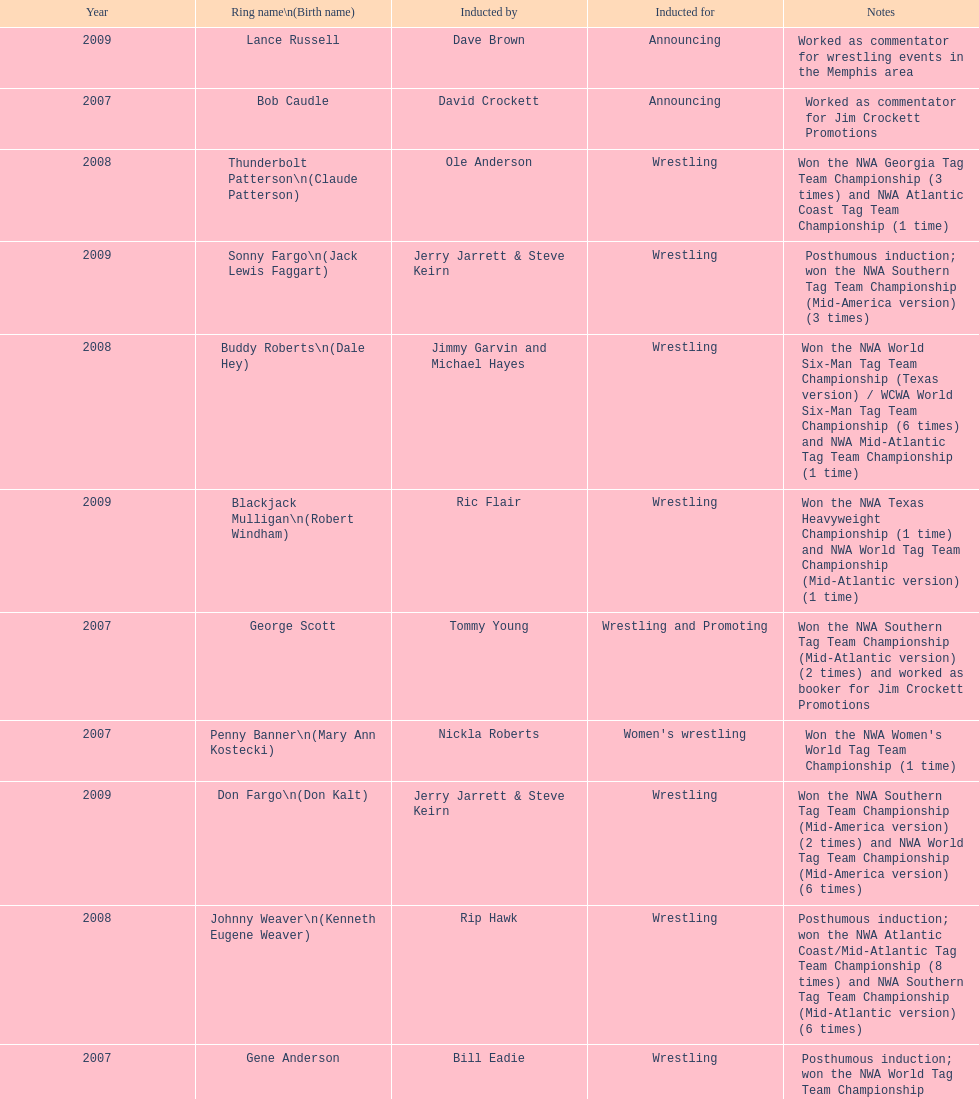I'm looking to parse the entire table for insights. Could you assist me with that? {'header': ['Year', 'Ring name\\n(Birth name)', 'Inducted by', 'Inducted for', 'Notes'], 'rows': [['2009', 'Lance Russell', 'Dave Brown', 'Announcing', 'Worked as commentator for wrestling events in the Memphis area'], ['2007', 'Bob Caudle', 'David Crockett', 'Announcing', 'Worked as commentator for Jim Crockett Promotions'], ['2008', 'Thunderbolt Patterson\\n(Claude Patterson)', 'Ole Anderson', 'Wrestling', 'Won the NWA Georgia Tag Team Championship (3 times) and NWA Atlantic Coast Tag Team Championship (1 time)'], ['2009', 'Sonny Fargo\\n(Jack Lewis Faggart)', 'Jerry Jarrett & Steve Keirn', 'Wrestling', 'Posthumous induction; won the NWA Southern Tag Team Championship (Mid-America version) (3 times)'], ['2008', 'Buddy Roberts\\n(Dale Hey)', 'Jimmy Garvin and Michael Hayes', 'Wrestling', 'Won the NWA World Six-Man Tag Team Championship (Texas version) / WCWA World Six-Man Tag Team Championship (6 times) and NWA Mid-Atlantic Tag Team Championship (1 time)'], ['2009', 'Blackjack Mulligan\\n(Robert Windham)', 'Ric Flair', 'Wrestling', 'Won the NWA Texas Heavyweight Championship (1 time) and NWA World Tag Team Championship (Mid-Atlantic version) (1 time)'], ['2007', 'George Scott', 'Tommy Young', 'Wrestling and Promoting', 'Won the NWA Southern Tag Team Championship (Mid-Atlantic version) (2 times) and worked as booker for Jim Crockett Promotions'], ['2007', 'Penny Banner\\n(Mary Ann Kostecki)', 'Nickla Roberts', "Women's wrestling", "Won the NWA Women's World Tag Team Championship (1 time)"], ['2009', 'Don Fargo\\n(Don Kalt)', 'Jerry Jarrett & Steve Keirn', 'Wrestling', 'Won the NWA Southern Tag Team Championship (Mid-America version) (2 times) and NWA World Tag Team Championship (Mid-America version) (6 times)'], ['2008', 'Johnny Weaver\\n(Kenneth Eugene Weaver)', 'Rip Hawk', 'Wrestling', 'Posthumous induction; won the NWA Atlantic Coast/Mid-Atlantic Tag Team Championship (8 times) and NWA Southern Tag Team Championship (Mid-Atlantic version) (6 times)'], ['2007', 'Gene Anderson', 'Bill Eadie', 'Wrestling', 'Posthumous induction; won the NWA World Tag Team Championship (Mid-Atlantic version) (7 times) and NWA Georgia Tag Team Championship (7 times)'], ['2008', 'Ivan Koloff\\n(Oreal Perras)', 'Don Kernodle', 'Wrestling', 'Won the NWA Mid-Atlantic Heavyweight Championship (3 times) and NWA World Tag Team Championship (Mid-Atlantic version) (4 times)'], ['2008', 'Grizzly Smith\\n(Aurelian Smith)', 'Magnum T.A.', 'Wrestling', 'Won the NWA United States Tag Team Championship (Tri-State version) (2 times) and NWA Texas Heavyweight Championship (1 time)'], ['2008', 'Sandy Scott\\n(Angus Mackay Scott)', 'Bob Caudle', 'Wrestling and Promoting', 'Worked as an executive for Jim Crockett Promotions and won the NWA World Tag Team Championship (Central States version) (1 time) and NWA Southern Tag Team Championship (Mid-Atlantic version) (3 times)'], ['2008', 'Paul Jones\\n(Paul Frederick)', 'Jack Brisco', 'Wrestling and Managing', "Won the NWA Mid-Atlantic Heavyweight Championship (3 times), NWA World Tag Team Championship (Mid-Atlantic version) (6 times), and NWA Mid-Atlantic/Atlantic Coast Tag Team Championship (6 times); managed Paul Jones' Army in Jim Crockett Promotions"], ['2007', 'Rip Hawk\\n(Harvey Evers)', 'Gary Hart', 'Wrestling', 'Won the NWA Eastern States Heavyweight Championship (4 times) and NWA Mid-Atlantic/Atlantic Coast Tag Team Championship (5 times)'], ['2009', 'Nelson Royal', 'Brad Anderson, Tommy Angel & David Isley', 'Wrestling', 'Won the NWA Atlantic Coast Tag Team Championship (2 times)'], ['2009', 'Wahoo McDaniel\\n(Edward McDaniel)', 'Tully Blanchard', 'Wrestling', 'Posthumous induction; won the NWA Mid-Atlantic Heavyweight Championship (6 times) and NWA World Tag Team Championship (Mid-Atlantic version) (4 times)'], ['2009', 'Jackie Fargo\\n(Henry Faggart)', 'Jerry Jarrett & Steve Keirn', 'Wrestling', 'Won the NWA World Tag Team Championship (Mid-America version) (10 times) and NWA Southern Tag Team Championship (Mid-America version) (22 times)'], ['2007', 'Ole Anderson\\n(Alan Rogowski)', 'Bill Eadie', 'Wrestling', 'Won the NWA Mid-Atlantic/Atlantic Coast Tag Team Championship (7 times) and NWA World Tag Team Championship (Mid-Atlantic version) (8 times)'], ['2007', 'Swede Hanson\\n(Robert Ford Hanson)', 'Gary Hart', 'Wrestling', 'Posthumous induction; won the NWA Atlantic Coast Tag Team Championship (4 times) and NWA Southern Tag Team Championship (Mid-Atlantic version) (1 time)'], ['2009', 'Gary Hart\\n(Gary Williams)', 'Sir Oliver Humperdink', 'Managing and Promoting', 'Posthumous induction; worked as a booker in World Class Championship Wrestling and managed several wrestlers in Mid-Atlantic Championship Wrestling']]} Who was inducted after royal? Lance Russell. 